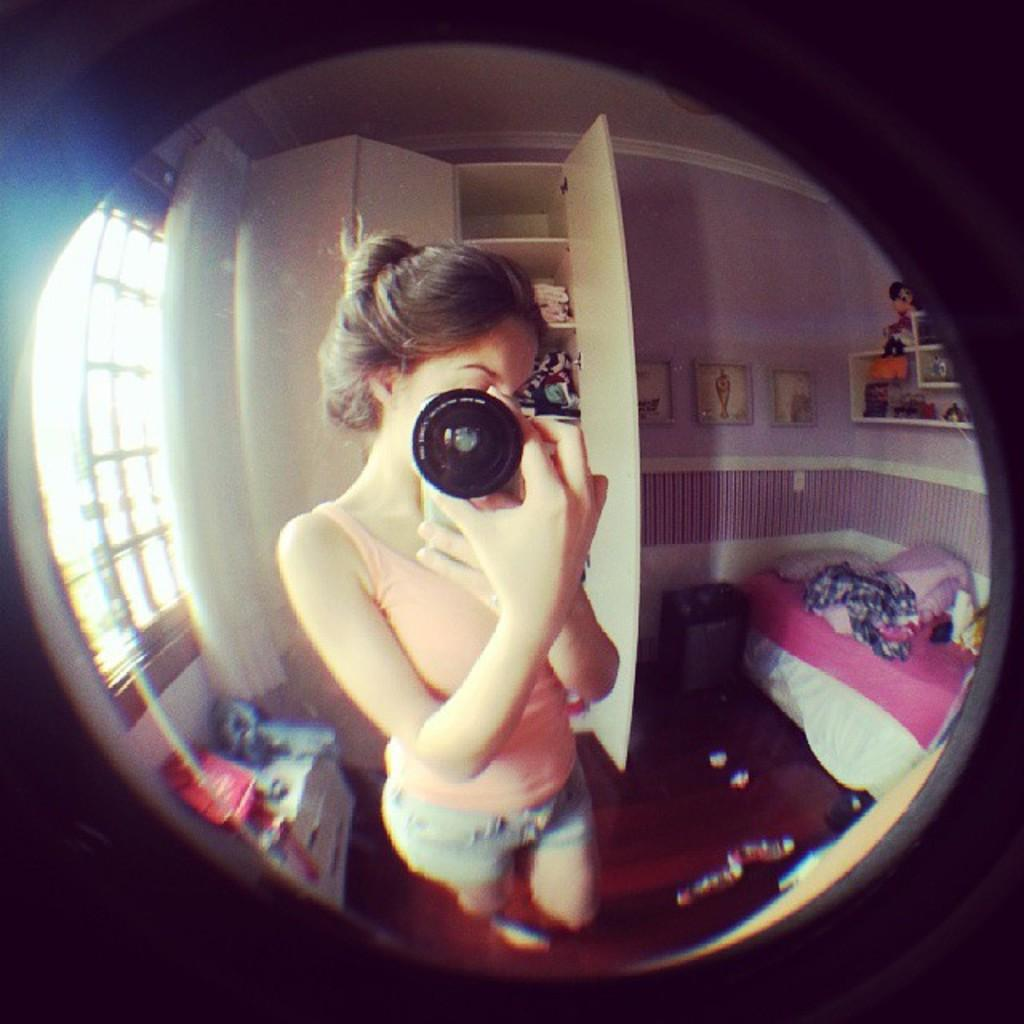Who is present in the image? There is a woman in the image. What is the woman doing in the image? The woman is standing in the image. What is the woman holding in the image? The woman is holding a box in the image. What type of furniture can be seen in the image? There is a bed in the image. What architectural feature is present in the image? There is a door in the image. What type of liquid can be seen on the moon in the image? There is no moon or liquid present in the image. What type of nut is the woman cracking in the image? There is no nut present in the image. 